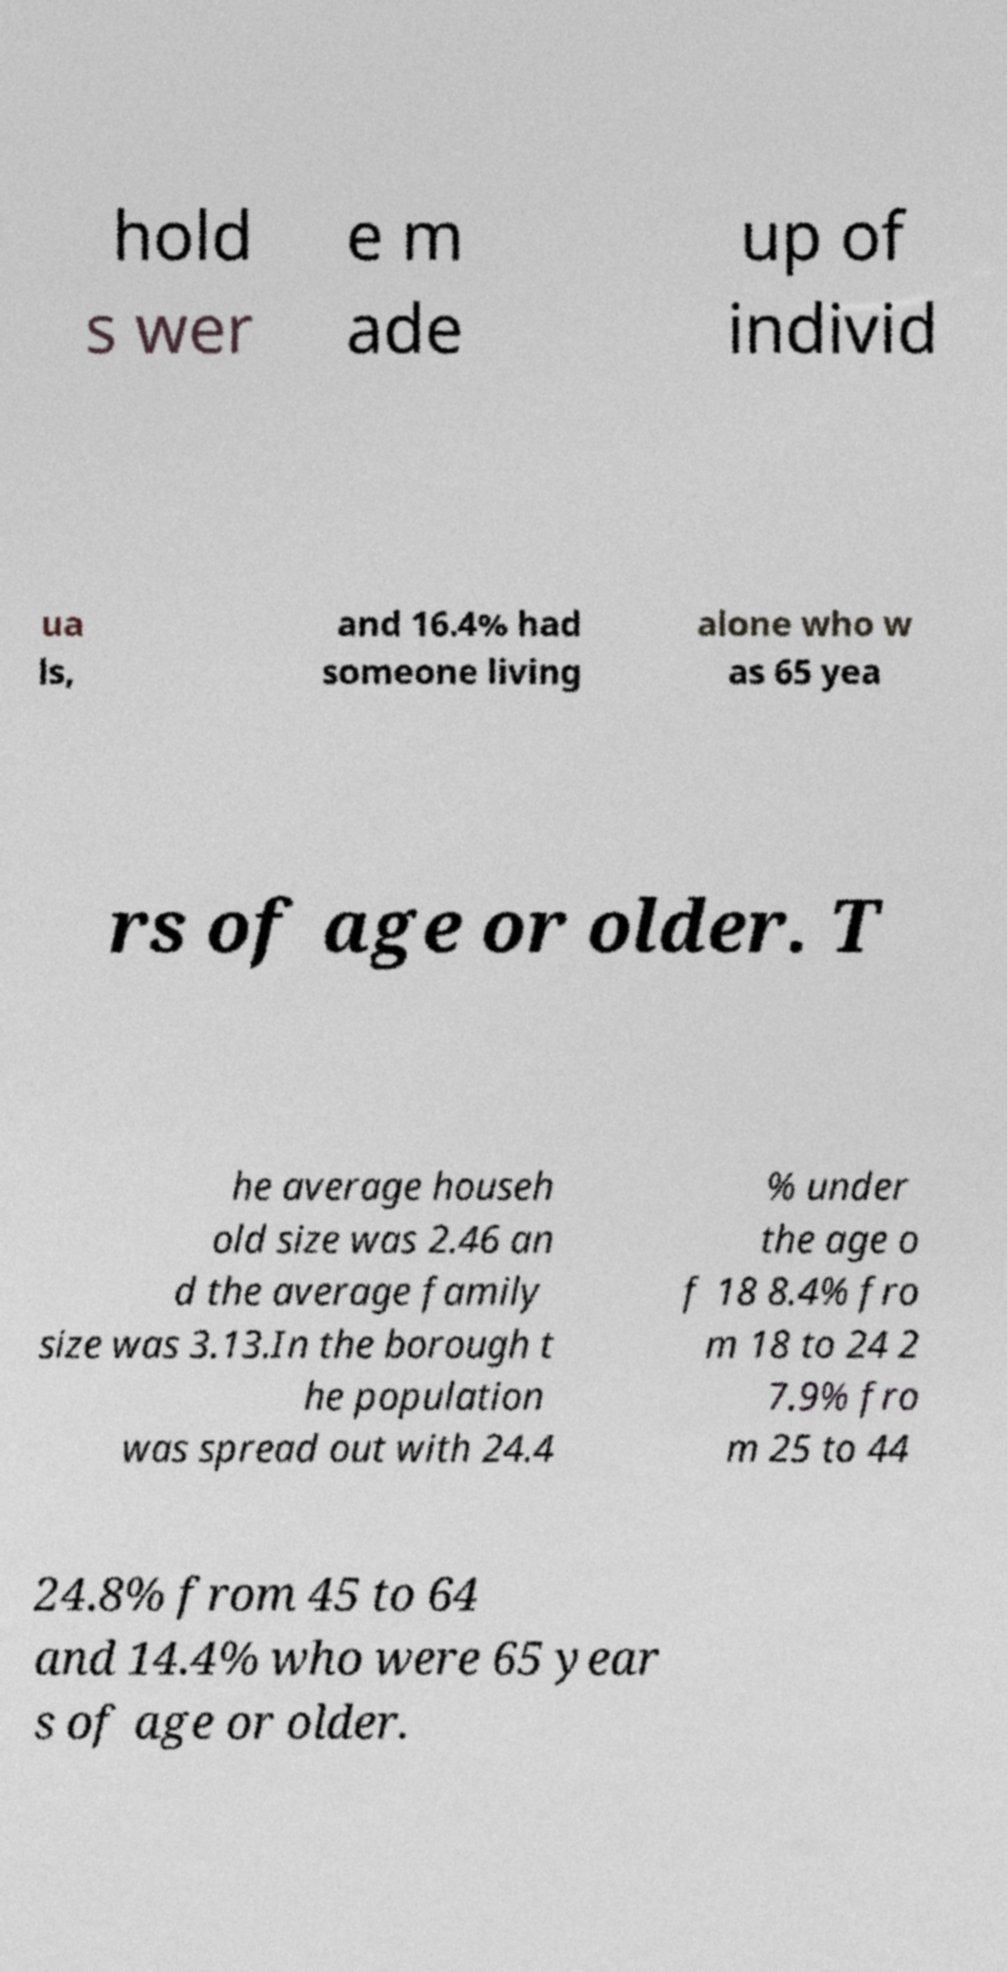Please read and relay the text visible in this image. What does it say? hold s wer e m ade up of individ ua ls, and 16.4% had someone living alone who w as 65 yea rs of age or older. T he average househ old size was 2.46 an d the average family size was 3.13.In the borough t he population was spread out with 24.4 % under the age o f 18 8.4% fro m 18 to 24 2 7.9% fro m 25 to 44 24.8% from 45 to 64 and 14.4% who were 65 year s of age or older. 